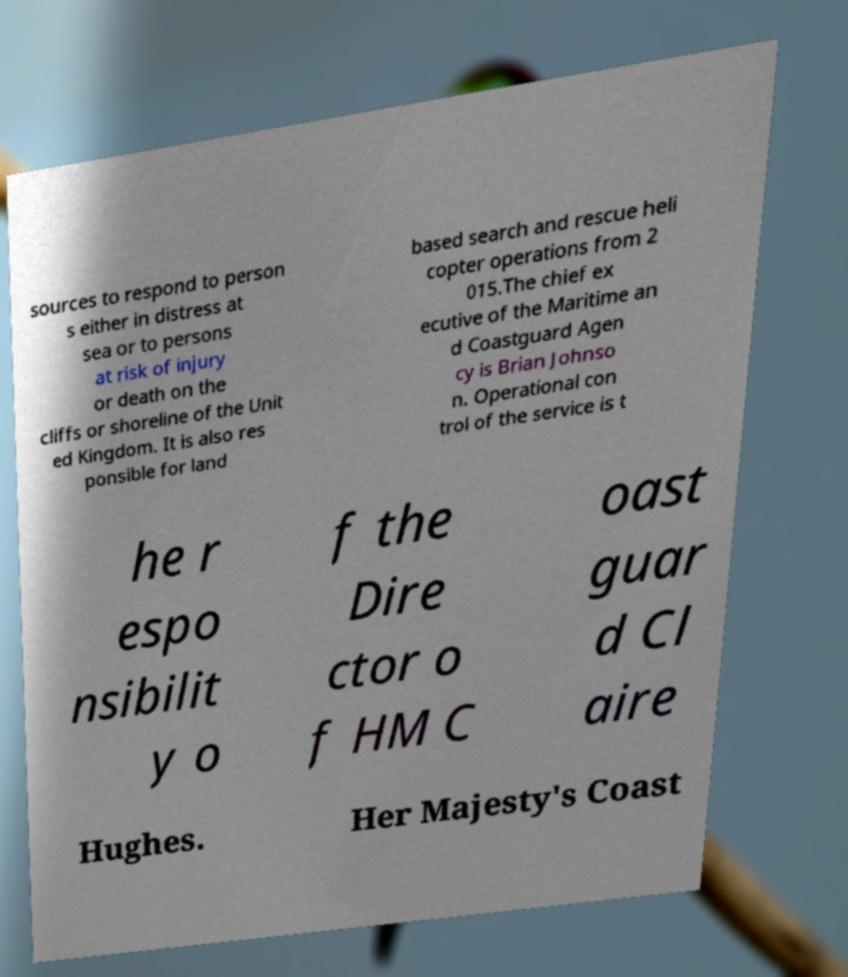What messages or text are displayed in this image? I need them in a readable, typed format. sources to respond to person s either in distress at sea or to persons at risk of injury or death on the cliffs or shoreline of the Unit ed Kingdom. It is also res ponsible for land based search and rescue heli copter operations from 2 015.The chief ex ecutive of the Maritime an d Coastguard Agen cy is Brian Johnso n. Operational con trol of the service is t he r espo nsibilit y o f the Dire ctor o f HM C oast guar d Cl aire Hughes. Her Majesty's Coast 